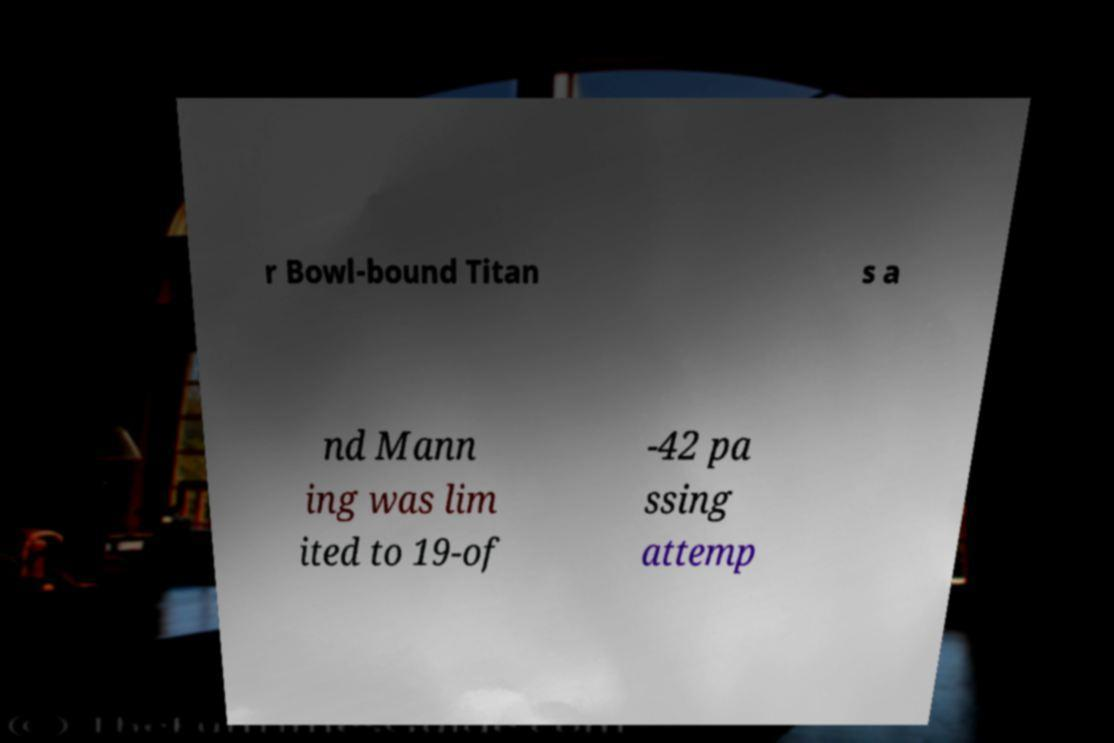Could you extract and type out the text from this image? r Bowl-bound Titan s a nd Mann ing was lim ited to 19-of -42 pa ssing attemp 